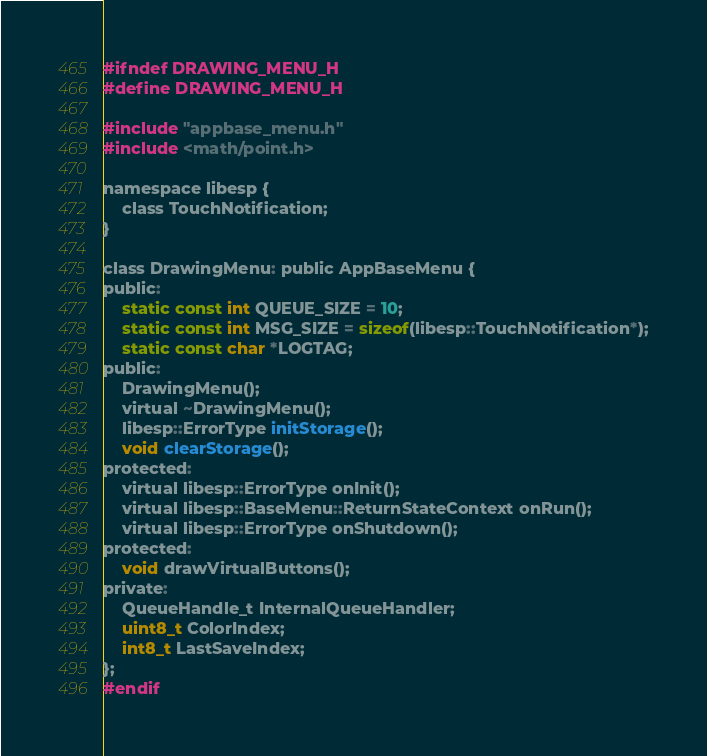Convert code to text. <code><loc_0><loc_0><loc_500><loc_500><_C_>#ifndef DRAWING_MENU_H
#define DRAWING_MENU_H

#include "appbase_menu.h"
#include <math/point.h>

namespace libesp {
	class TouchNotification;
}

class DrawingMenu: public AppBaseMenu {
public:
	static const int QUEUE_SIZE = 10;
	static const int MSG_SIZE = sizeof(libesp::TouchNotification*);
	static const char *LOGTAG;
public:
	DrawingMenu();
	virtual ~DrawingMenu();
	libesp::ErrorType initStorage();
	void clearStorage();
protected:
	virtual libesp::ErrorType onInit();
	virtual libesp::BaseMenu::ReturnStateContext onRun();
	virtual libesp::ErrorType onShutdown();
protected:
	void drawVirtualButtons();
private:
	QueueHandle_t InternalQueueHandler;
	uint8_t ColorIndex;	
	int8_t LastSaveIndex;
};
#endif
</code> 